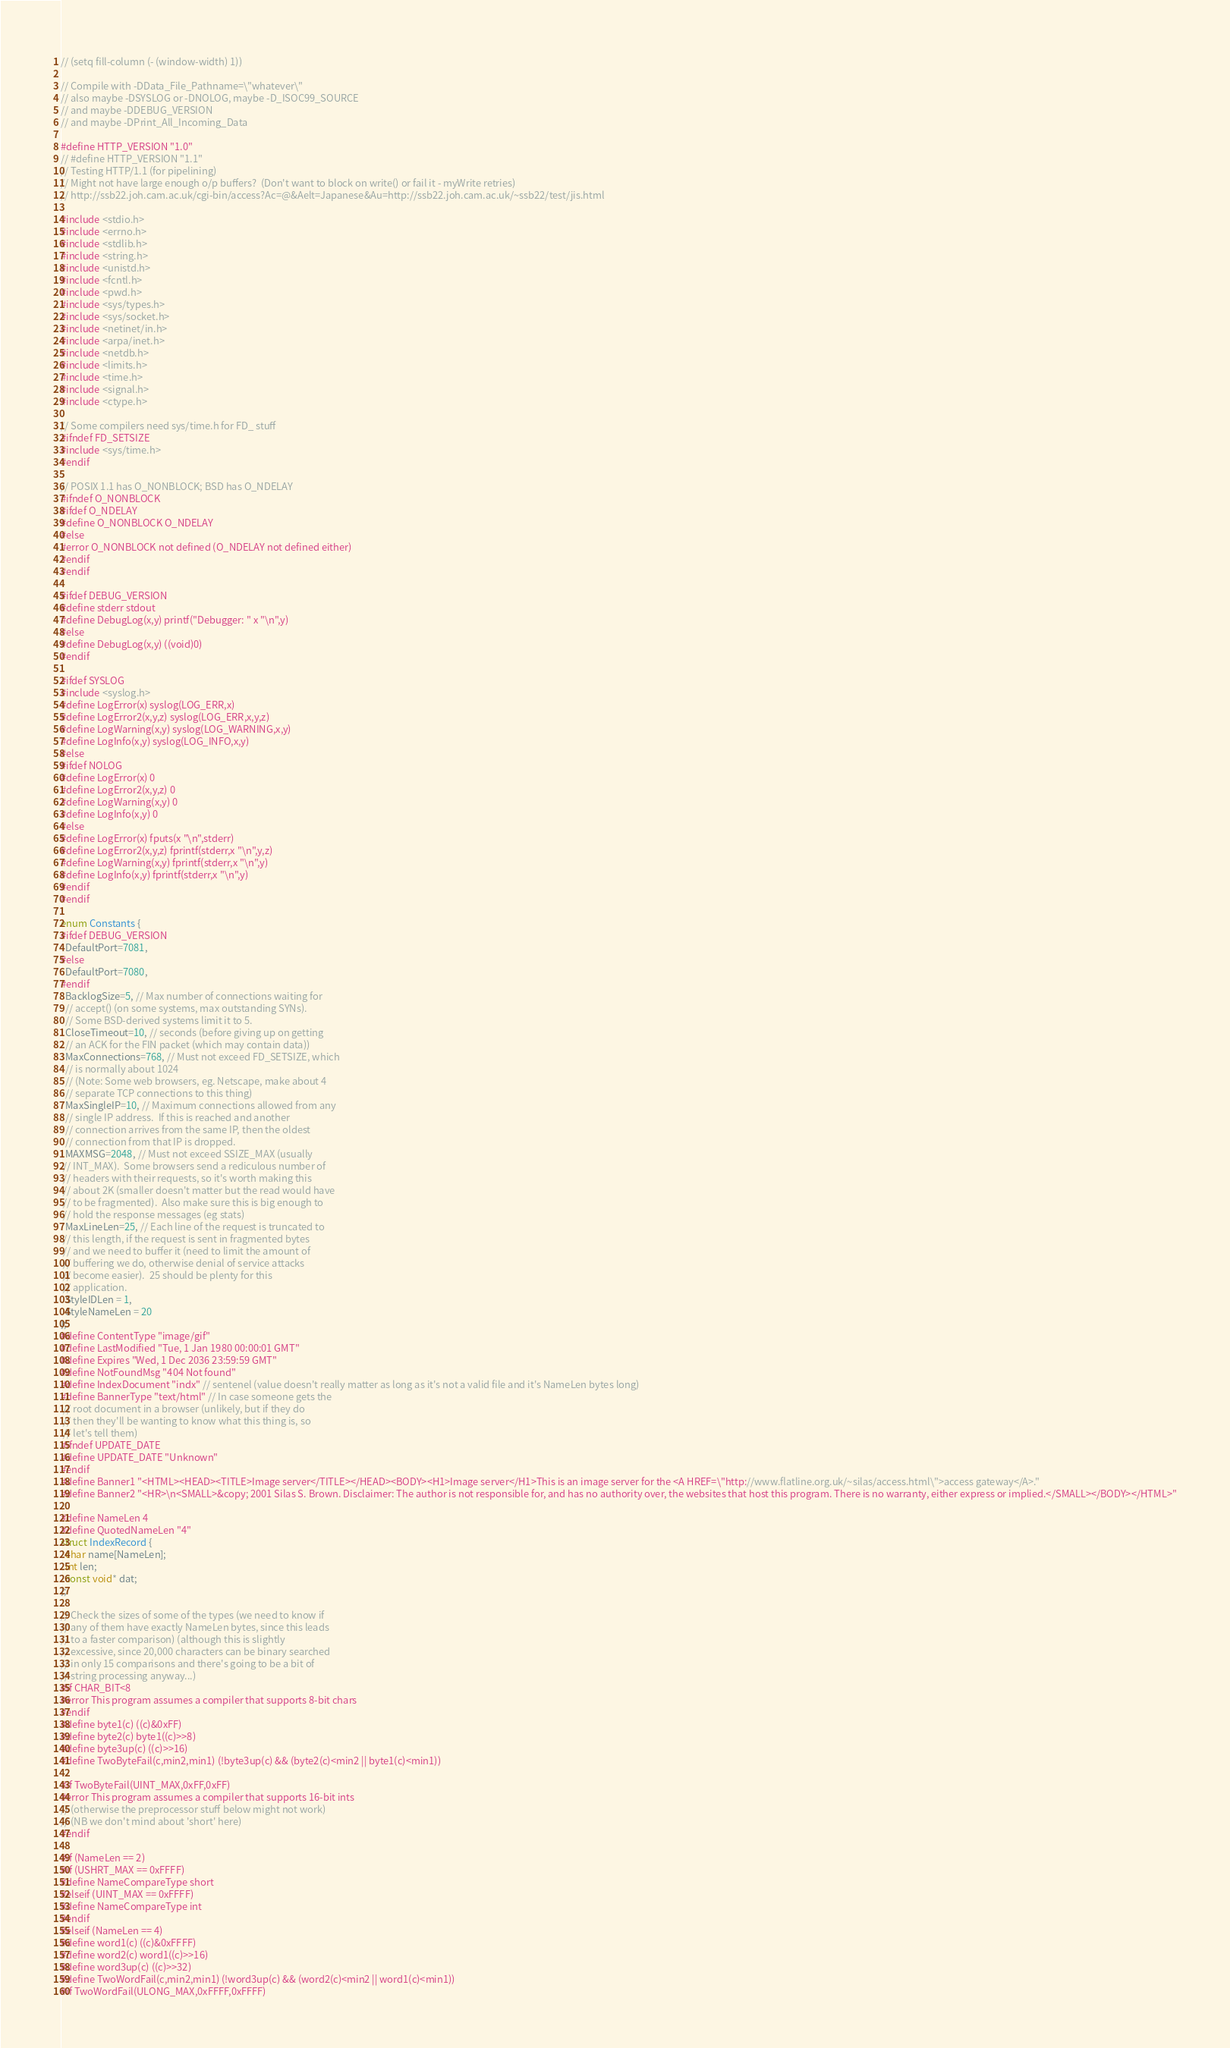<code> <loc_0><loc_0><loc_500><loc_500><_C++_>// (setq fill-column (- (window-width) 1))

// Compile with -DData_File_Pathname=\"whatever\"
// also maybe -DSYSLOG or -DNOLOG, maybe -D_ISOC99_SOURCE
// and maybe -DDEBUG_VERSION
// and maybe -DPrint_All_Incoming_Data

#define HTTP_VERSION "1.0"
// #define HTTP_VERSION "1.1"
// Testing HTTP/1.1 (for pipelining)
// Might not have large enough o/p buffers?  (Don't want to block on write() or fail it - myWrite retries)
// http://ssb22.joh.cam.ac.uk/cgi-bin/access?Ac=@&Aelt=Japanese&Au=http://ssb22.joh.cam.ac.uk/~ssb22/test/jis.html

#include <stdio.h>
#include <errno.h>
#include <stdlib.h>
#include <string.h>
#include <unistd.h>
#include <fcntl.h>
#include <pwd.h>
#include <sys/types.h>
#include <sys/socket.h>
#include <netinet/in.h>
#include <arpa/inet.h>
#include <netdb.h>
#include <limits.h>
#include <time.h>
#include <signal.h>
#include <ctype.h>

// Some compilers need sys/time.h for FD_ stuff
#ifndef FD_SETSIZE
#include <sys/time.h>
#endif

// POSIX 1.1 has O_NONBLOCK; BSD has O_NDELAY
#ifndef O_NONBLOCK
#ifdef O_NDELAY
#define O_NONBLOCK O_NDELAY
#else
#error O_NONBLOCK not defined (O_NDELAY not defined either)
#endif
#endif

#ifdef DEBUG_VERSION
#define stderr stdout
#define DebugLog(x,y) printf("Debugger: " x "\n",y)
#else
#define DebugLog(x,y) ((void)0)
#endif

#ifdef SYSLOG
#include <syslog.h>
#define LogError(x) syslog(LOG_ERR,x)
#define LogError2(x,y,z) syslog(LOG_ERR,x,y,z)
#define LogWarning(x,y) syslog(LOG_WARNING,x,y)
#define LogInfo(x,y) syslog(LOG_INFO,x,y)
#else
#ifdef NOLOG
#define LogError(x) 0
#define LogError2(x,y,z) 0
#define LogWarning(x,y) 0
#define LogInfo(x,y) 0
#else
#define LogError(x) fputs(x "\n",stderr)
#define LogError2(x,y,z) fprintf(stderr,x "\n",y,z)
#define LogWarning(x,y) fprintf(stderr,x "\n",y)
#define LogInfo(x,y) fprintf(stderr,x "\n",y)
#endif
#endif

enum Constants {
#ifdef DEBUG_VERSION
  DefaultPort=7081,
#else
  DefaultPort=7080,
#endif
  BacklogSize=5, // Max number of connections waiting for
  // accept() (on some systems, max outstanding SYNs).
  // Some BSD-derived systems limit it to 5.
  CloseTimeout=10, // seconds (before giving up on getting
  // an ACK for the FIN packet (which may contain data))
  MaxConnections=768, // Must not exceed FD_SETSIZE, which
  // is normally about 1024
  // (Note: Some web browsers, eg. Netscape, make about 4
  // separate TCP connections to this thing)
  MaxSingleIP=10, // Maximum connections allowed from any
  // single IP address.  If this is reached and another
  // connection arrives from the same IP, then the oldest
  // connection from that IP is dropped.
  MAXMSG=2048, // Must not exceed SSIZE_MAX (usually
 // INT_MAX).  Some browsers send a rediculous number of
 // headers with their requests, so it's worth making this
 // about 2K (smaller doesn't matter but the read would have
 // to be fragmented).  Also make sure this is big enough to
 // hold the response messages (eg stats)
  MaxLineLen=25, // Each line of the request is truncated to
 // this length, if the request is sent in fragmented bytes
 // and we need to buffer it (need to limit the amount of
 // buffering we do, otherwise denial of service attacks
 // become easier).  25 should be plenty for this
 // application.
  StyleIDLen = 1,
  StyleNameLen = 20
};
#define ContentType "image/gif"
#define LastModified "Tue, 1 Jan 1980 00:00:01 GMT"
#define Expires "Wed, 1 Dec 2036 23:59:59 GMT"
#define NotFoundMsg "404 Not found"
#define IndexDocument "indx" // sentenel (value doesn't really matter as long as it's not a valid file and it's NameLen bytes long)
#define BannerType "text/html" // In case someone gets the
 // root document in a browser (unlikely, but if they do
 // then they'll be wanting to know what this thing is, so
 // let's tell them)
#ifndef UPDATE_DATE
#define UPDATE_DATE "Unknown"
#endif
#define Banner1 "<HTML><HEAD><TITLE>Image server</TITLE></HEAD><BODY><H1>Image server</H1>This is an image server for the <A HREF=\"http://www.flatline.org.uk/~silas/access.html\">access gateway</A>."
#define Banner2 "<HR>\n<SMALL>&copy; 2001 Silas S. Brown. Disclaimer: The author is not responsible for, and has no authority over, the websites that host this program. There is no warranty, either express or implied.</SMALL></BODY></HTML>"

#define NameLen 4
#define QuotedNameLen "4"
struct IndexRecord {
  char name[NameLen];
  int len;
  const void* dat;
};

// Check the sizes of some of the types (we need to know if
// any of them have exactly NameLen bytes, since this leads
// to a faster comparison) (although this is slightly
// excessive, since 20,000 characters can be binary searched
// in only 15 comparisons and there's going to be a bit of
// string processing anyway...)
#if CHAR_BIT<8
#error This program assumes a compiler that supports 8-bit chars
#endif
#define byte1(c) ((c)&0xFF)
#define byte2(c) byte1((c)>>8)
#define byte3up(c) ((c)>>16)
#define TwoByteFail(c,min2,min1) (!byte3up(c) && (byte2(c)<min2 || byte1(c)<min1))

#if TwoByteFail(UINT_MAX,0xFF,0xFF)
#error This program assumes a compiler that supports 16-bit ints
// (otherwise the preprocessor stuff below might not work)
// (NB we don't mind about 'short' here)
#endif

#if (NameLen == 2)
#if (USHRT_MAX == 0xFFFF)
#define NameCompareType short
#elseif (UINT_MAX == 0xFFFF)
#define NameCompareType int
#endif
#elseif (NameLen == 4)
#define word1(c) ((c)&0xFFFF)
#define word2(c) word1((c)>>16)
#define word3up(c) ((c)>>32)
#define TwoWordFail(c,min2,min1) (!word3up(c) && (word2(c)<min2 || word1(c)<min1))
#if TwoWordFail(ULONG_MAX,0xFFFF,0xFFFF)</code> 